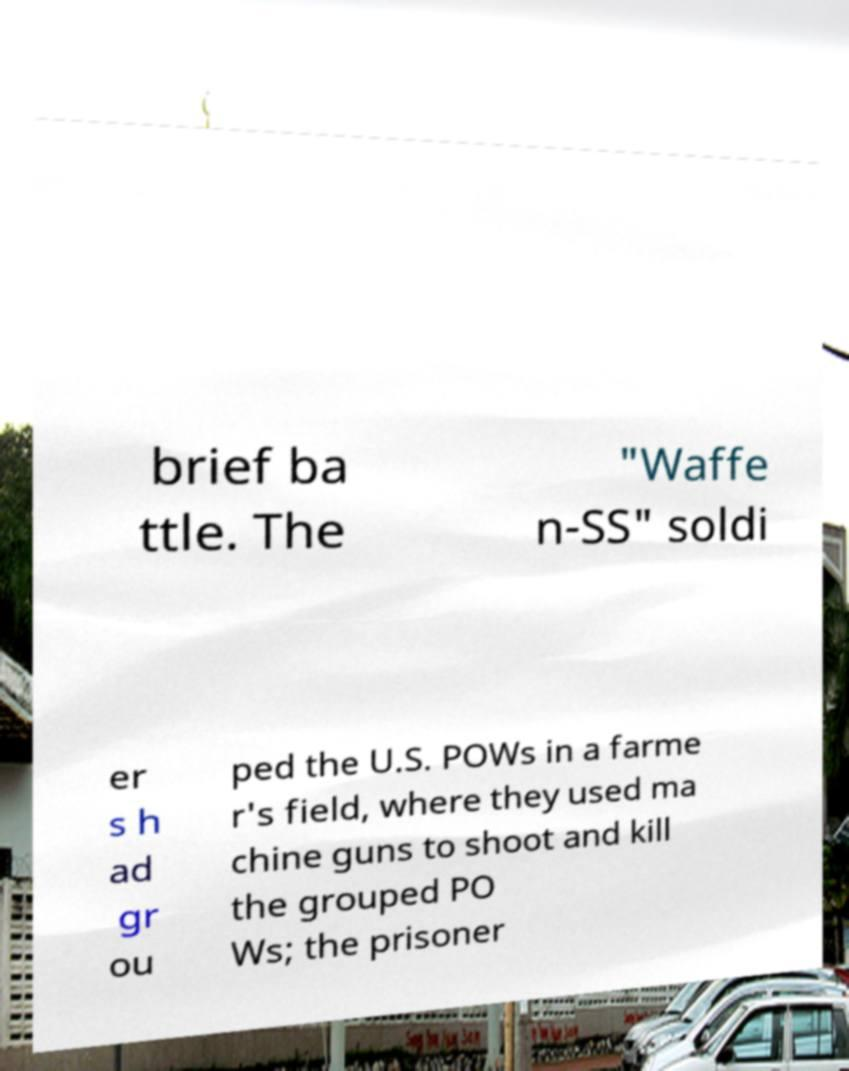What messages or text are displayed in this image? I need them in a readable, typed format. brief ba ttle. The "Waffe n-SS" soldi er s h ad gr ou ped the U.S. POWs in a farme r's field, where they used ma chine guns to shoot and kill the grouped PO Ws; the prisoner 